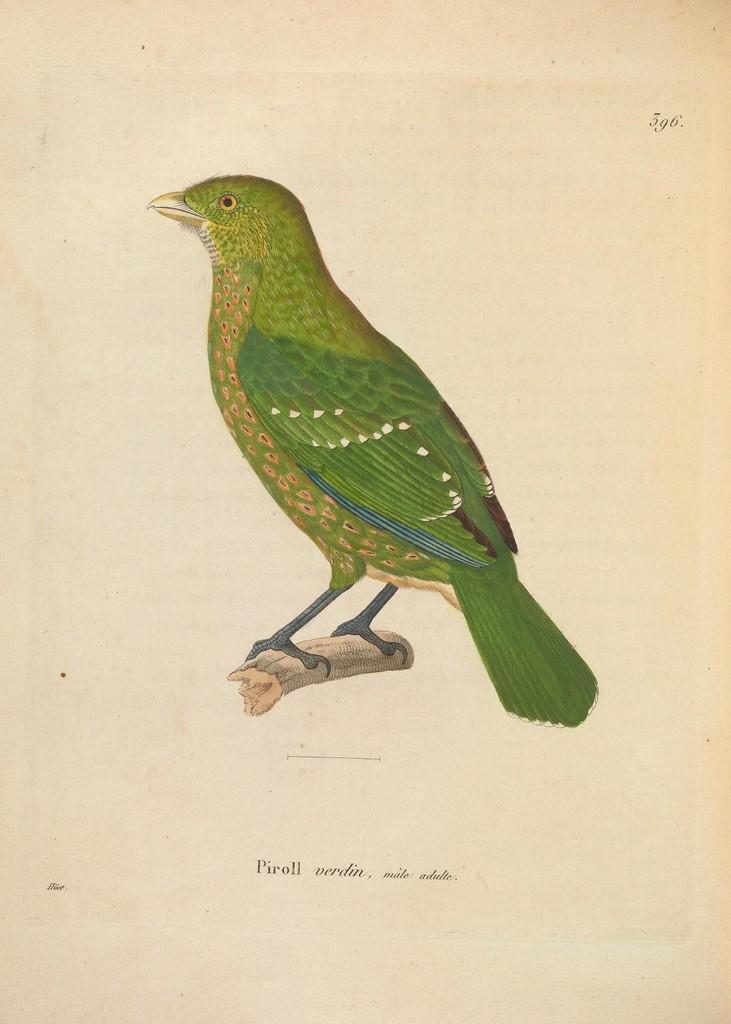What type of images are on the paper in the image? There are pictures of a bird and a stick on the paper. What else can be found on the paper besides the images? There is text on the paper. What type of frame is holding the kite in the image? There is no kite present in the image, so there is no frame holding a kite. 